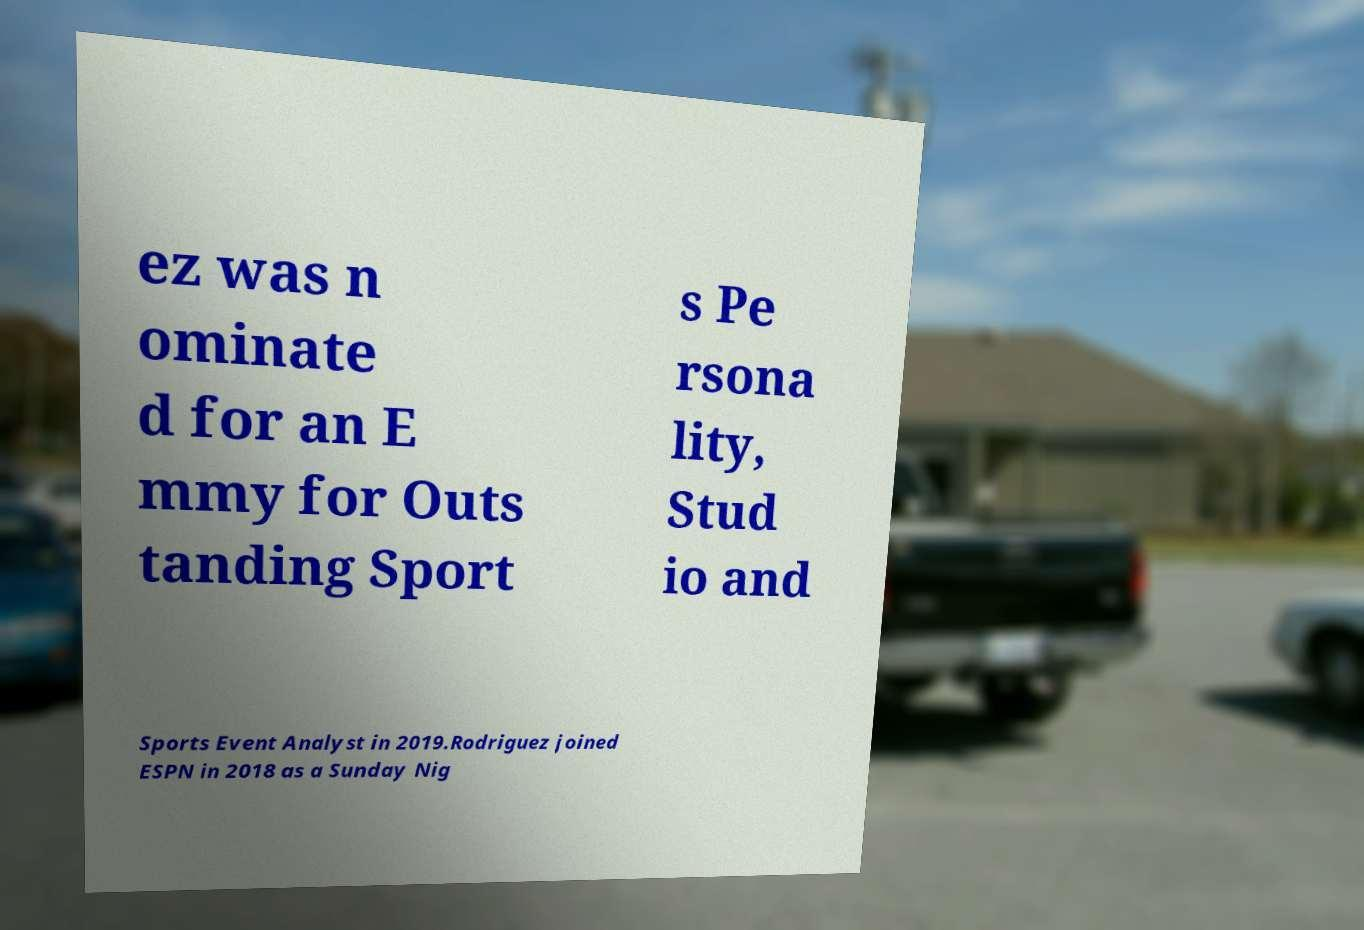Could you assist in decoding the text presented in this image and type it out clearly? ez was n ominate d for an E mmy for Outs tanding Sport s Pe rsona lity, Stud io and Sports Event Analyst in 2019.Rodriguez joined ESPN in 2018 as a Sunday Nig 